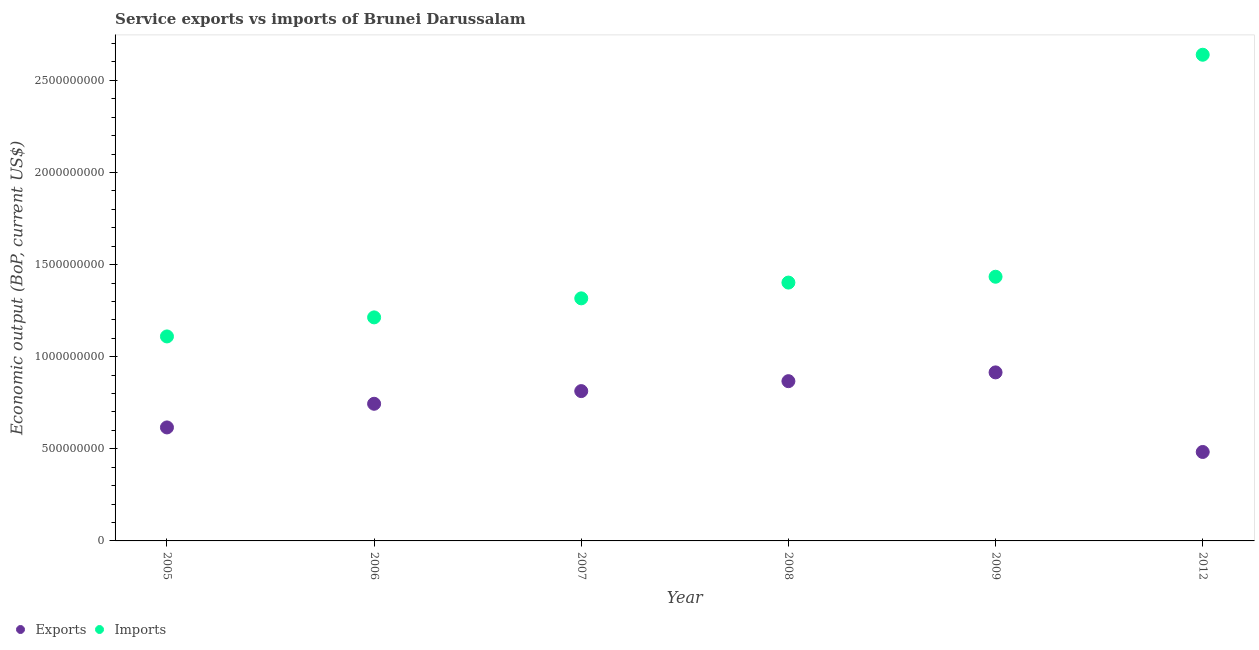How many different coloured dotlines are there?
Make the answer very short. 2. What is the amount of service exports in 2008?
Make the answer very short. 8.67e+08. Across all years, what is the maximum amount of service exports?
Provide a succinct answer. 9.15e+08. Across all years, what is the minimum amount of service exports?
Keep it short and to the point. 4.83e+08. What is the total amount of service imports in the graph?
Provide a short and direct response. 9.12e+09. What is the difference between the amount of service imports in 2005 and that in 2012?
Your answer should be compact. -1.53e+09. What is the difference between the amount of service exports in 2005 and the amount of service imports in 2009?
Make the answer very short. -8.18e+08. What is the average amount of service imports per year?
Give a very brief answer. 1.52e+09. In the year 2007, what is the difference between the amount of service exports and amount of service imports?
Ensure brevity in your answer.  -5.03e+08. What is the ratio of the amount of service exports in 2006 to that in 2007?
Ensure brevity in your answer.  0.92. Is the amount of service exports in 2005 less than that in 2012?
Your response must be concise. No. What is the difference between the highest and the second highest amount of service imports?
Ensure brevity in your answer.  1.21e+09. What is the difference between the highest and the lowest amount of service imports?
Ensure brevity in your answer.  1.53e+09. Does the amount of service exports monotonically increase over the years?
Your answer should be very brief. No. How many dotlines are there?
Make the answer very short. 2. How many years are there in the graph?
Keep it short and to the point. 6. Are the values on the major ticks of Y-axis written in scientific E-notation?
Offer a very short reply. No. Does the graph contain any zero values?
Make the answer very short. No. Where does the legend appear in the graph?
Make the answer very short. Bottom left. How many legend labels are there?
Ensure brevity in your answer.  2. What is the title of the graph?
Give a very brief answer. Service exports vs imports of Brunei Darussalam. Does "Imports" appear as one of the legend labels in the graph?
Your response must be concise. Yes. What is the label or title of the Y-axis?
Your answer should be very brief. Economic output (BoP, current US$). What is the Economic output (BoP, current US$) in Exports in 2005?
Provide a short and direct response. 6.16e+08. What is the Economic output (BoP, current US$) in Imports in 2005?
Provide a succinct answer. 1.11e+09. What is the Economic output (BoP, current US$) of Exports in 2006?
Give a very brief answer. 7.45e+08. What is the Economic output (BoP, current US$) in Imports in 2006?
Offer a terse response. 1.21e+09. What is the Economic output (BoP, current US$) of Exports in 2007?
Give a very brief answer. 8.13e+08. What is the Economic output (BoP, current US$) in Imports in 2007?
Provide a succinct answer. 1.32e+09. What is the Economic output (BoP, current US$) in Exports in 2008?
Your answer should be very brief. 8.67e+08. What is the Economic output (BoP, current US$) in Imports in 2008?
Offer a terse response. 1.40e+09. What is the Economic output (BoP, current US$) of Exports in 2009?
Offer a terse response. 9.15e+08. What is the Economic output (BoP, current US$) of Imports in 2009?
Keep it short and to the point. 1.43e+09. What is the Economic output (BoP, current US$) in Exports in 2012?
Make the answer very short. 4.83e+08. What is the Economic output (BoP, current US$) of Imports in 2012?
Keep it short and to the point. 2.64e+09. Across all years, what is the maximum Economic output (BoP, current US$) in Exports?
Provide a succinct answer. 9.15e+08. Across all years, what is the maximum Economic output (BoP, current US$) in Imports?
Your response must be concise. 2.64e+09. Across all years, what is the minimum Economic output (BoP, current US$) in Exports?
Your response must be concise. 4.83e+08. Across all years, what is the minimum Economic output (BoP, current US$) of Imports?
Your answer should be very brief. 1.11e+09. What is the total Economic output (BoP, current US$) of Exports in the graph?
Make the answer very short. 4.44e+09. What is the total Economic output (BoP, current US$) in Imports in the graph?
Ensure brevity in your answer.  9.12e+09. What is the difference between the Economic output (BoP, current US$) in Exports in 2005 and that in 2006?
Keep it short and to the point. -1.28e+08. What is the difference between the Economic output (BoP, current US$) of Imports in 2005 and that in 2006?
Your answer should be compact. -1.03e+08. What is the difference between the Economic output (BoP, current US$) of Exports in 2005 and that in 2007?
Provide a succinct answer. -1.97e+08. What is the difference between the Economic output (BoP, current US$) in Imports in 2005 and that in 2007?
Your response must be concise. -2.07e+08. What is the difference between the Economic output (BoP, current US$) in Exports in 2005 and that in 2008?
Your response must be concise. -2.51e+08. What is the difference between the Economic output (BoP, current US$) in Imports in 2005 and that in 2008?
Ensure brevity in your answer.  -2.92e+08. What is the difference between the Economic output (BoP, current US$) in Exports in 2005 and that in 2009?
Provide a short and direct response. -2.99e+08. What is the difference between the Economic output (BoP, current US$) in Imports in 2005 and that in 2009?
Provide a succinct answer. -3.24e+08. What is the difference between the Economic output (BoP, current US$) in Exports in 2005 and that in 2012?
Your answer should be compact. 1.33e+08. What is the difference between the Economic output (BoP, current US$) of Imports in 2005 and that in 2012?
Provide a short and direct response. -1.53e+09. What is the difference between the Economic output (BoP, current US$) in Exports in 2006 and that in 2007?
Give a very brief answer. -6.88e+07. What is the difference between the Economic output (BoP, current US$) of Imports in 2006 and that in 2007?
Offer a terse response. -1.03e+08. What is the difference between the Economic output (BoP, current US$) of Exports in 2006 and that in 2008?
Your answer should be very brief. -1.23e+08. What is the difference between the Economic output (BoP, current US$) in Imports in 2006 and that in 2008?
Keep it short and to the point. -1.89e+08. What is the difference between the Economic output (BoP, current US$) of Exports in 2006 and that in 2009?
Provide a short and direct response. -1.70e+08. What is the difference between the Economic output (BoP, current US$) of Imports in 2006 and that in 2009?
Make the answer very short. -2.21e+08. What is the difference between the Economic output (BoP, current US$) in Exports in 2006 and that in 2012?
Offer a terse response. 2.62e+08. What is the difference between the Economic output (BoP, current US$) in Imports in 2006 and that in 2012?
Make the answer very short. -1.43e+09. What is the difference between the Economic output (BoP, current US$) in Exports in 2007 and that in 2008?
Offer a very short reply. -5.39e+07. What is the difference between the Economic output (BoP, current US$) in Imports in 2007 and that in 2008?
Provide a succinct answer. -8.57e+07. What is the difference between the Economic output (BoP, current US$) of Exports in 2007 and that in 2009?
Offer a very short reply. -1.02e+08. What is the difference between the Economic output (BoP, current US$) of Imports in 2007 and that in 2009?
Your response must be concise. -1.17e+08. What is the difference between the Economic output (BoP, current US$) of Exports in 2007 and that in 2012?
Your answer should be very brief. 3.30e+08. What is the difference between the Economic output (BoP, current US$) in Imports in 2007 and that in 2012?
Keep it short and to the point. -1.32e+09. What is the difference between the Economic output (BoP, current US$) of Exports in 2008 and that in 2009?
Make the answer very short. -4.77e+07. What is the difference between the Economic output (BoP, current US$) in Imports in 2008 and that in 2009?
Your response must be concise. -3.17e+07. What is the difference between the Economic output (BoP, current US$) in Exports in 2008 and that in 2012?
Keep it short and to the point. 3.84e+08. What is the difference between the Economic output (BoP, current US$) of Imports in 2008 and that in 2012?
Provide a short and direct response. -1.24e+09. What is the difference between the Economic output (BoP, current US$) of Exports in 2009 and that in 2012?
Provide a succinct answer. 4.32e+08. What is the difference between the Economic output (BoP, current US$) of Imports in 2009 and that in 2012?
Your answer should be compact. -1.21e+09. What is the difference between the Economic output (BoP, current US$) in Exports in 2005 and the Economic output (BoP, current US$) in Imports in 2006?
Your answer should be very brief. -5.97e+08. What is the difference between the Economic output (BoP, current US$) of Exports in 2005 and the Economic output (BoP, current US$) of Imports in 2007?
Your answer should be very brief. -7.01e+08. What is the difference between the Economic output (BoP, current US$) of Exports in 2005 and the Economic output (BoP, current US$) of Imports in 2008?
Provide a succinct answer. -7.86e+08. What is the difference between the Economic output (BoP, current US$) in Exports in 2005 and the Economic output (BoP, current US$) in Imports in 2009?
Give a very brief answer. -8.18e+08. What is the difference between the Economic output (BoP, current US$) in Exports in 2005 and the Economic output (BoP, current US$) in Imports in 2012?
Provide a succinct answer. -2.02e+09. What is the difference between the Economic output (BoP, current US$) of Exports in 2006 and the Economic output (BoP, current US$) of Imports in 2007?
Your answer should be very brief. -5.72e+08. What is the difference between the Economic output (BoP, current US$) in Exports in 2006 and the Economic output (BoP, current US$) in Imports in 2008?
Provide a succinct answer. -6.58e+08. What is the difference between the Economic output (BoP, current US$) of Exports in 2006 and the Economic output (BoP, current US$) of Imports in 2009?
Provide a short and direct response. -6.90e+08. What is the difference between the Economic output (BoP, current US$) in Exports in 2006 and the Economic output (BoP, current US$) in Imports in 2012?
Ensure brevity in your answer.  -1.89e+09. What is the difference between the Economic output (BoP, current US$) of Exports in 2007 and the Economic output (BoP, current US$) of Imports in 2008?
Your answer should be very brief. -5.89e+08. What is the difference between the Economic output (BoP, current US$) in Exports in 2007 and the Economic output (BoP, current US$) in Imports in 2009?
Make the answer very short. -6.21e+08. What is the difference between the Economic output (BoP, current US$) in Exports in 2007 and the Economic output (BoP, current US$) in Imports in 2012?
Provide a short and direct response. -1.83e+09. What is the difference between the Economic output (BoP, current US$) of Exports in 2008 and the Economic output (BoP, current US$) of Imports in 2009?
Your answer should be very brief. -5.67e+08. What is the difference between the Economic output (BoP, current US$) in Exports in 2008 and the Economic output (BoP, current US$) in Imports in 2012?
Offer a very short reply. -1.77e+09. What is the difference between the Economic output (BoP, current US$) in Exports in 2009 and the Economic output (BoP, current US$) in Imports in 2012?
Provide a short and direct response. -1.72e+09. What is the average Economic output (BoP, current US$) in Exports per year?
Give a very brief answer. 7.40e+08. What is the average Economic output (BoP, current US$) in Imports per year?
Provide a succinct answer. 1.52e+09. In the year 2005, what is the difference between the Economic output (BoP, current US$) of Exports and Economic output (BoP, current US$) of Imports?
Ensure brevity in your answer.  -4.94e+08. In the year 2006, what is the difference between the Economic output (BoP, current US$) of Exports and Economic output (BoP, current US$) of Imports?
Your response must be concise. -4.69e+08. In the year 2007, what is the difference between the Economic output (BoP, current US$) of Exports and Economic output (BoP, current US$) of Imports?
Your answer should be very brief. -5.03e+08. In the year 2008, what is the difference between the Economic output (BoP, current US$) of Exports and Economic output (BoP, current US$) of Imports?
Provide a short and direct response. -5.35e+08. In the year 2009, what is the difference between the Economic output (BoP, current US$) in Exports and Economic output (BoP, current US$) in Imports?
Provide a succinct answer. -5.19e+08. In the year 2012, what is the difference between the Economic output (BoP, current US$) in Exports and Economic output (BoP, current US$) in Imports?
Make the answer very short. -2.16e+09. What is the ratio of the Economic output (BoP, current US$) of Exports in 2005 to that in 2006?
Give a very brief answer. 0.83. What is the ratio of the Economic output (BoP, current US$) in Imports in 2005 to that in 2006?
Offer a terse response. 0.91. What is the ratio of the Economic output (BoP, current US$) of Exports in 2005 to that in 2007?
Ensure brevity in your answer.  0.76. What is the ratio of the Economic output (BoP, current US$) in Imports in 2005 to that in 2007?
Provide a succinct answer. 0.84. What is the ratio of the Economic output (BoP, current US$) in Exports in 2005 to that in 2008?
Offer a terse response. 0.71. What is the ratio of the Economic output (BoP, current US$) in Imports in 2005 to that in 2008?
Give a very brief answer. 0.79. What is the ratio of the Economic output (BoP, current US$) of Exports in 2005 to that in 2009?
Your answer should be very brief. 0.67. What is the ratio of the Economic output (BoP, current US$) in Imports in 2005 to that in 2009?
Your answer should be very brief. 0.77. What is the ratio of the Economic output (BoP, current US$) of Exports in 2005 to that in 2012?
Ensure brevity in your answer.  1.28. What is the ratio of the Economic output (BoP, current US$) of Imports in 2005 to that in 2012?
Ensure brevity in your answer.  0.42. What is the ratio of the Economic output (BoP, current US$) in Exports in 2006 to that in 2007?
Your answer should be very brief. 0.92. What is the ratio of the Economic output (BoP, current US$) of Imports in 2006 to that in 2007?
Provide a short and direct response. 0.92. What is the ratio of the Economic output (BoP, current US$) of Exports in 2006 to that in 2008?
Give a very brief answer. 0.86. What is the ratio of the Economic output (BoP, current US$) in Imports in 2006 to that in 2008?
Your answer should be very brief. 0.87. What is the ratio of the Economic output (BoP, current US$) of Exports in 2006 to that in 2009?
Offer a terse response. 0.81. What is the ratio of the Economic output (BoP, current US$) in Imports in 2006 to that in 2009?
Give a very brief answer. 0.85. What is the ratio of the Economic output (BoP, current US$) in Exports in 2006 to that in 2012?
Provide a short and direct response. 1.54. What is the ratio of the Economic output (BoP, current US$) in Imports in 2006 to that in 2012?
Your answer should be very brief. 0.46. What is the ratio of the Economic output (BoP, current US$) of Exports in 2007 to that in 2008?
Provide a short and direct response. 0.94. What is the ratio of the Economic output (BoP, current US$) in Imports in 2007 to that in 2008?
Offer a terse response. 0.94. What is the ratio of the Economic output (BoP, current US$) of Exports in 2007 to that in 2009?
Offer a very short reply. 0.89. What is the ratio of the Economic output (BoP, current US$) of Imports in 2007 to that in 2009?
Keep it short and to the point. 0.92. What is the ratio of the Economic output (BoP, current US$) in Exports in 2007 to that in 2012?
Give a very brief answer. 1.68. What is the ratio of the Economic output (BoP, current US$) in Imports in 2007 to that in 2012?
Make the answer very short. 0.5. What is the ratio of the Economic output (BoP, current US$) of Exports in 2008 to that in 2009?
Your response must be concise. 0.95. What is the ratio of the Economic output (BoP, current US$) of Imports in 2008 to that in 2009?
Offer a terse response. 0.98. What is the ratio of the Economic output (BoP, current US$) in Exports in 2008 to that in 2012?
Offer a very short reply. 1.8. What is the ratio of the Economic output (BoP, current US$) of Imports in 2008 to that in 2012?
Offer a terse response. 0.53. What is the ratio of the Economic output (BoP, current US$) of Exports in 2009 to that in 2012?
Ensure brevity in your answer.  1.89. What is the ratio of the Economic output (BoP, current US$) of Imports in 2009 to that in 2012?
Provide a short and direct response. 0.54. What is the difference between the highest and the second highest Economic output (BoP, current US$) of Exports?
Provide a succinct answer. 4.77e+07. What is the difference between the highest and the second highest Economic output (BoP, current US$) in Imports?
Offer a terse response. 1.21e+09. What is the difference between the highest and the lowest Economic output (BoP, current US$) in Exports?
Provide a short and direct response. 4.32e+08. What is the difference between the highest and the lowest Economic output (BoP, current US$) in Imports?
Your answer should be very brief. 1.53e+09. 